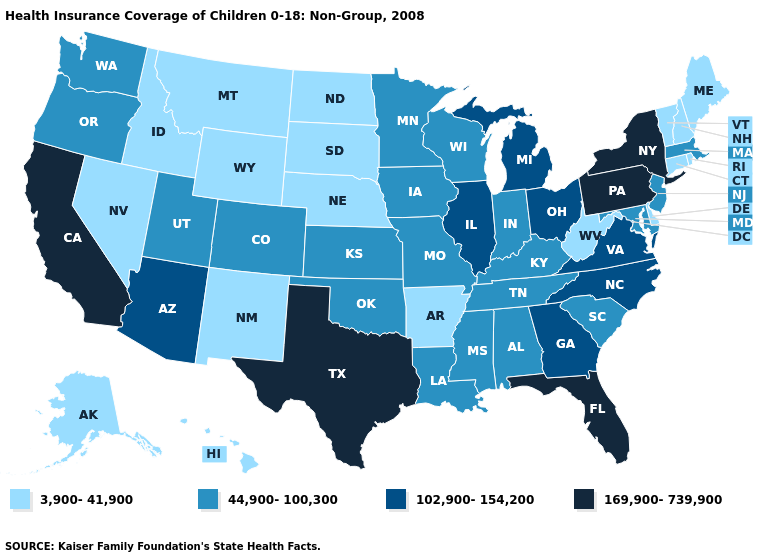What is the value of Tennessee?
Be succinct. 44,900-100,300. What is the value of Florida?
Quick response, please. 169,900-739,900. Name the states that have a value in the range 102,900-154,200?
Concise answer only. Arizona, Georgia, Illinois, Michigan, North Carolina, Ohio, Virginia. What is the value of Georgia?
Be succinct. 102,900-154,200. Does Minnesota have the highest value in the USA?
Short answer required. No. What is the value of Illinois?
Concise answer only. 102,900-154,200. What is the highest value in states that border New Jersey?
Answer briefly. 169,900-739,900. How many symbols are there in the legend?
Keep it brief. 4. Does the map have missing data?
Quick response, please. No. What is the lowest value in the USA?
Give a very brief answer. 3,900-41,900. What is the value of Wisconsin?
Keep it brief. 44,900-100,300. Does the first symbol in the legend represent the smallest category?
Answer briefly. Yes. Name the states that have a value in the range 169,900-739,900?
Answer briefly. California, Florida, New York, Pennsylvania, Texas. Name the states that have a value in the range 102,900-154,200?
Quick response, please. Arizona, Georgia, Illinois, Michigan, North Carolina, Ohio, Virginia. What is the lowest value in the USA?
Short answer required. 3,900-41,900. 